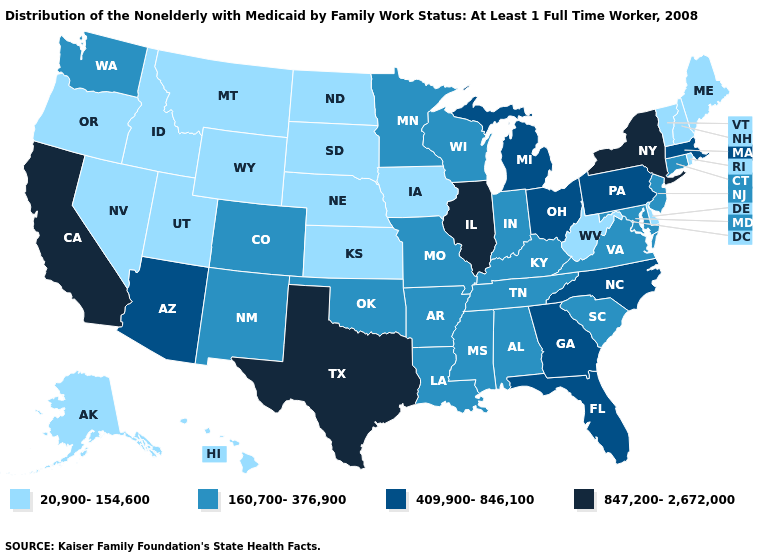Among the states that border Wisconsin , does Iowa have the lowest value?
Concise answer only. Yes. What is the highest value in the West ?
Give a very brief answer. 847,200-2,672,000. Name the states that have a value in the range 160,700-376,900?
Short answer required. Alabama, Arkansas, Colorado, Connecticut, Indiana, Kentucky, Louisiana, Maryland, Minnesota, Mississippi, Missouri, New Jersey, New Mexico, Oklahoma, South Carolina, Tennessee, Virginia, Washington, Wisconsin. Does South Dakota have the lowest value in the USA?
Concise answer only. Yes. Does the first symbol in the legend represent the smallest category?
Short answer required. Yes. What is the value of Pennsylvania?
Write a very short answer. 409,900-846,100. Among the states that border Utah , does Wyoming have the lowest value?
Short answer required. Yes. Does Iowa have the same value as Utah?
Short answer required. Yes. What is the value of Arizona?
Write a very short answer. 409,900-846,100. Among the states that border Connecticut , which have the lowest value?
Give a very brief answer. Rhode Island. What is the lowest value in the USA?
Give a very brief answer. 20,900-154,600. Is the legend a continuous bar?
Be succinct. No. What is the value of California?
Be succinct. 847,200-2,672,000. What is the value of Delaware?
Answer briefly. 20,900-154,600. Name the states that have a value in the range 409,900-846,100?
Quick response, please. Arizona, Florida, Georgia, Massachusetts, Michigan, North Carolina, Ohio, Pennsylvania. 